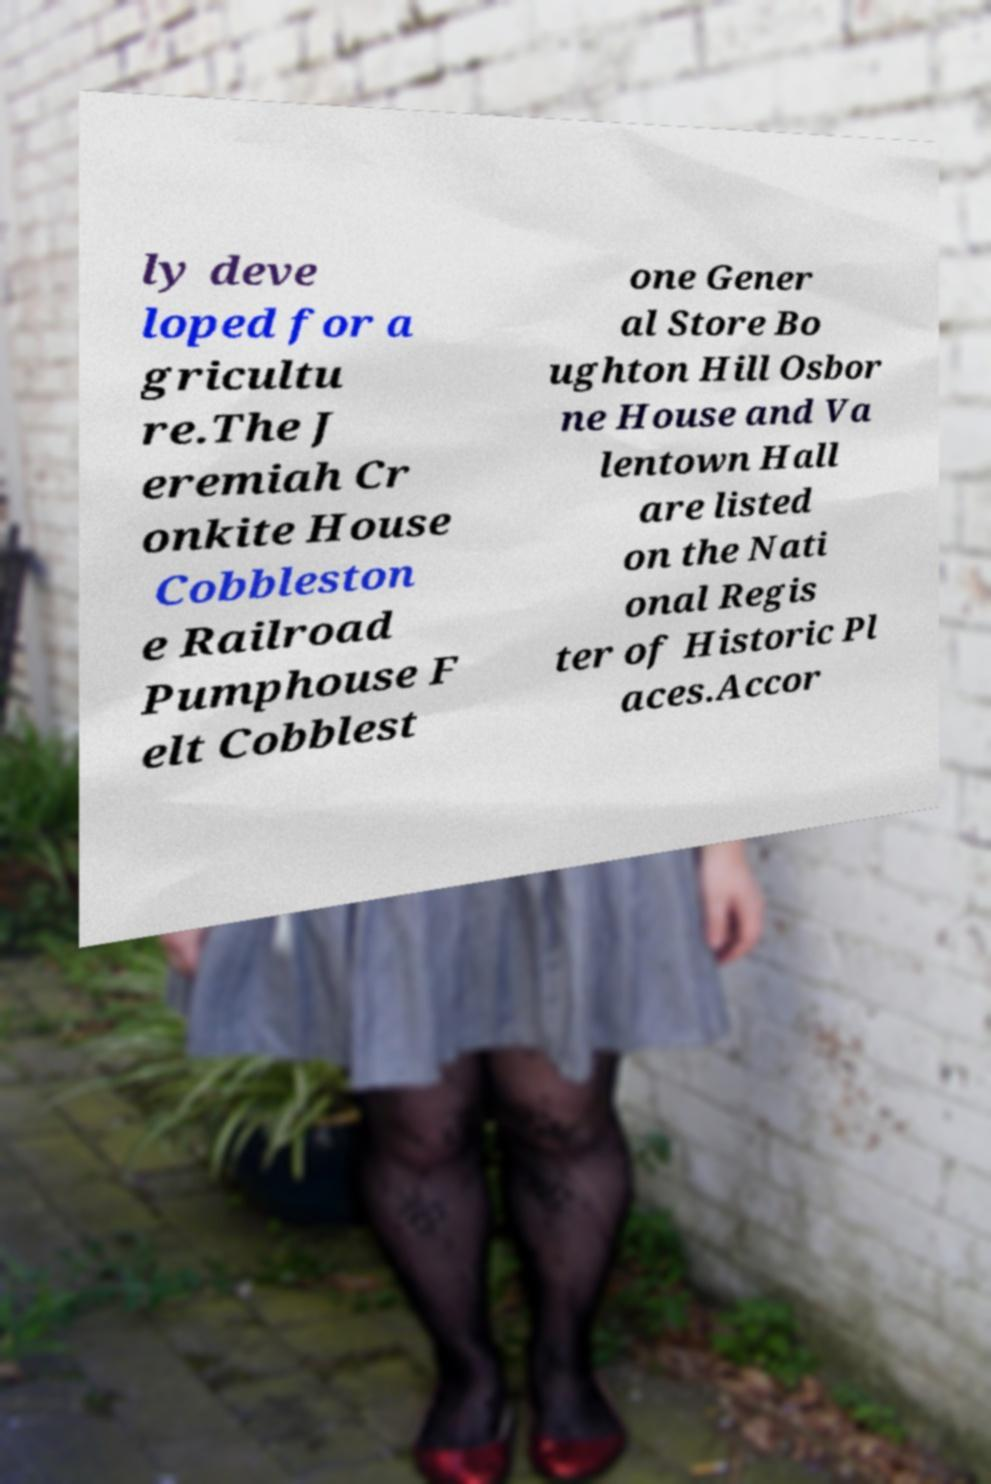What messages or text are displayed in this image? I need them in a readable, typed format. ly deve loped for a gricultu re.The J eremiah Cr onkite House Cobbleston e Railroad Pumphouse F elt Cobblest one Gener al Store Bo ughton Hill Osbor ne House and Va lentown Hall are listed on the Nati onal Regis ter of Historic Pl aces.Accor 